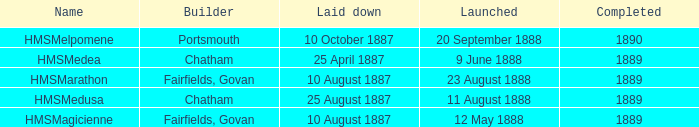Could you help me parse every detail presented in this table? {'header': ['Name', 'Builder', 'Laid down', 'Launched', 'Completed'], 'rows': [['HMSMelpomene', 'Portsmouth', '10 October 1887', '20 September 1888', '1890'], ['HMSMedea', 'Chatham', '25 April 1887', '9 June 1888', '1889'], ['HMSMarathon', 'Fairfields, Govan', '10 August 1887', '23 August 1888', '1889'], ['HMSMedusa', 'Chatham', '25 August 1887', '11 August 1888', '1889'], ['HMSMagicienne', 'Fairfields, Govan', '10 August 1887', '12 May 1888', '1889']]} What boat was laid down on 25 april 1887? HMSMedea. 